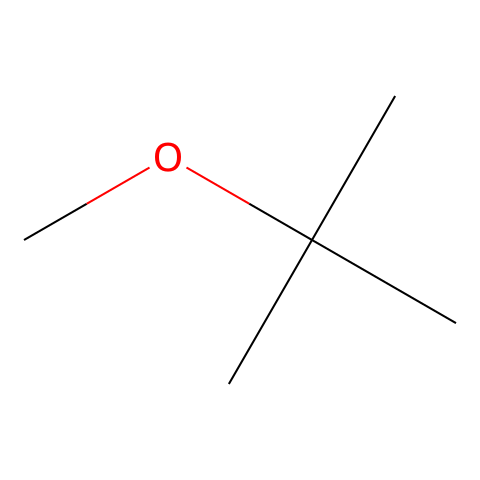What is the molecular formula of this compound? The SMILES representation provides information about the atoms present in the molecule. For the structure given, there are 5 carbon atoms (C) and 12 hydrogen atoms (H) along with 1 oxygen atom (O). Therefore, the molecular formula is derived as C5H12O.
Answer: C5H12O How many tertiary carbon atoms are in this molecule? By analyzing the structure, a tertiary carbon is defined as a carbon atom bonded to three other carbon atoms. In the given SMILES, there is one carbon atom that is connected to three different carbon atoms, making it tertiary.
Answer: 1 What functional group is present in MTBE? The given structure contains an ether functional group which is characterized by the presence of an oxygen atom connected to two alkyl or aryl groups, as seen in the structure.
Answer: ether How many total hydrogen atoms are connected to the carbon backbone? We can observe from the structure: there are 12 hydrogen atoms total connected to the carbon atoms in the molecule: 9 from the three methyl groups and 3 from the central carbon.
Answer: 12 Is this compound polar or non-polar? The presence of the ether functional group introduces polarity due to the electronegative oxygen atom. However, the bulky tert-butyl groups make the overall molecule more non-polar, suggesting a weak polar character.
Answer: non-polar Can this compound be categorized as a fuel additive? MTBE is synthesized primarily to serve as a gasoline additive to increase octane levels and reduce engine knocking. Its application in fuel makes it a relevant candidate in this category.
Answer: yes 